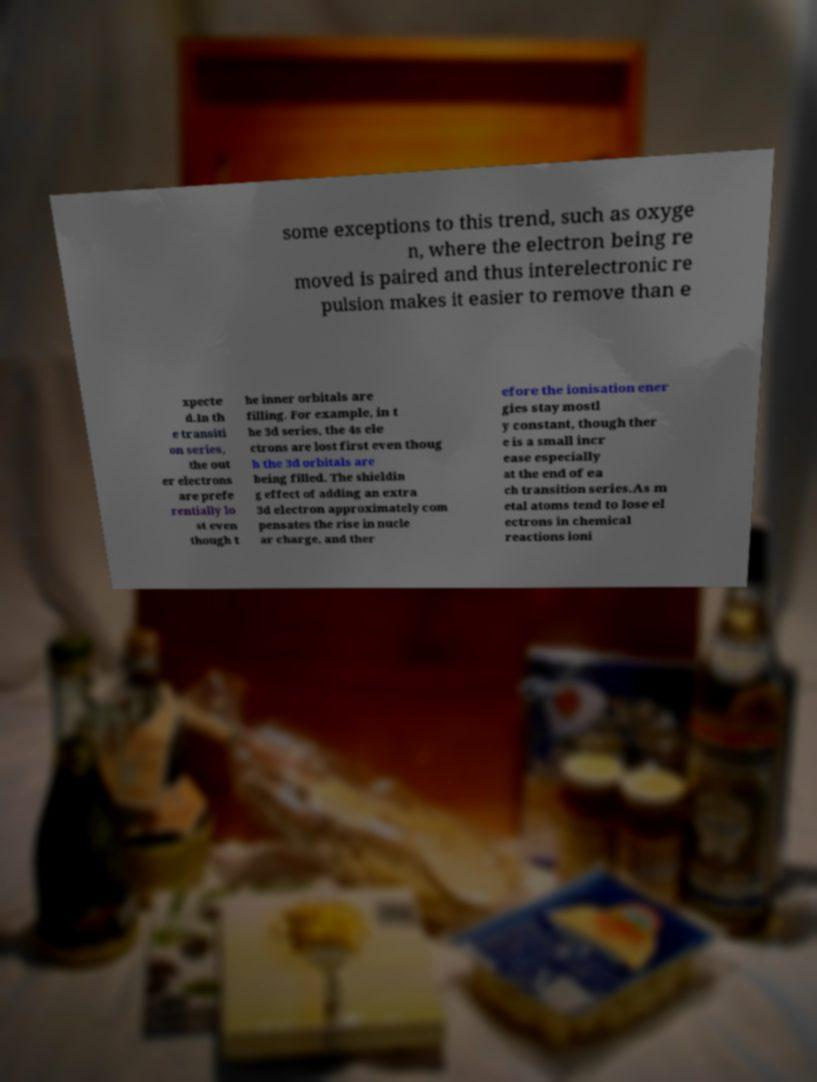For documentation purposes, I need the text within this image transcribed. Could you provide that? some exceptions to this trend, such as oxyge n, where the electron being re moved is paired and thus interelectronic re pulsion makes it easier to remove than e xpecte d.In th e transiti on series, the out er electrons are prefe rentially lo st even though t he inner orbitals are filling. For example, in t he 3d series, the 4s ele ctrons are lost first even thoug h the 3d orbitals are being filled. The shieldin g effect of adding an extra 3d electron approximately com pensates the rise in nucle ar charge, and ther efore the ionisation ener gies stay mostl y constant, though ther e is a small incr ease especially at the end of ea ch transition series.As m etal atoms tend to lose el ectrons in chemical reactions ioni 